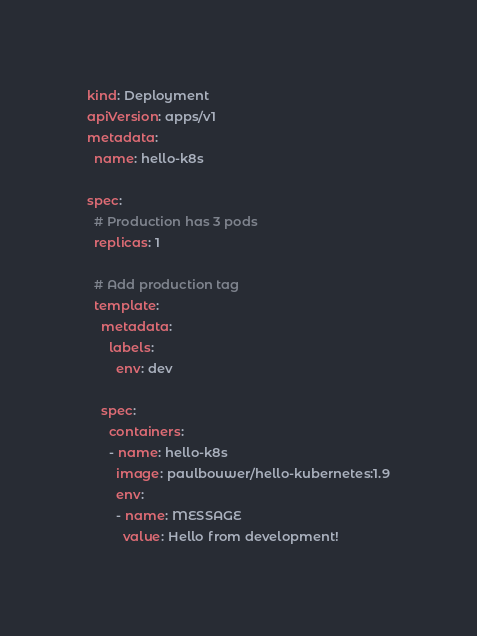Convert code to text. <code><loc_0><loc_0><loc_500><loc_500><_YAML_>kind: Deployment
apiVersion: apps/v1
metadata:
  name: hello-k8s

spec:
  # Production has 3 pods
  replicas: 1

  # Add production tag
  template:
    metadata:
      labels:
        env: dev

    spec:
      containers:
      - name: hello-k8s
        image: paulbouwer/hello-kubernetes:1.9
        env:
        - name: MESSAGE
          value: Hello from development!
</code> 